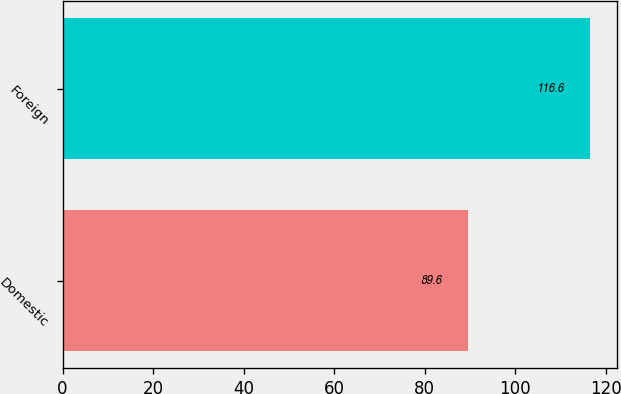Convert chart to OTSL. <chart><loc_0><loc_0><loc_500><loc_500><bar_chart><fcel>Domestic<fcel>Foreign<nl><fcel>89.6<fcel>116.6<nl></chart> 